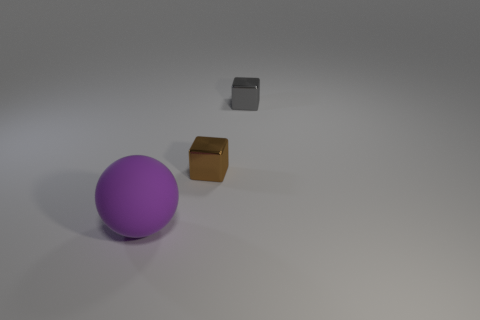The cube that is the same size as the gray object is what color?
Provide a short and direct response. Brown. Are there more tiny brown metallic cubes that are behind the gray cube than large yellow matte cylinders?
Offer a very short reply. No. What is the object that is both behind the big matte object and left of the small gray metal object made of?
Make the answer very short. Metal. There is a thing that is left of the brown shiny thing; is its color the same as the tiny metal cube that is behind the brown metal block?
Provide a succinct answer. No. How many other things are the same size as the purple rubber sphere?
Keep it short and to the point. 0. Are there the same number of large cyan cylinders and small cubes?
Provide a succinct answer. No. Are there any tiny gray shiny blocks that are left of the tiny object behind the metal thing that is on the left side of the gray object?
Provide a succinct answer. No. Do the small object that is on the left side of the small gray shiny thing and the tiny gray cube have the same material?
Give a very brief answer. Yes. The other tiny object that is the same shape as the tiny brown object is what color?
Keep it short and to the point. Gray. Is there any other thing that has the same shape as the purple object?
Your answer should be very brief. No. 